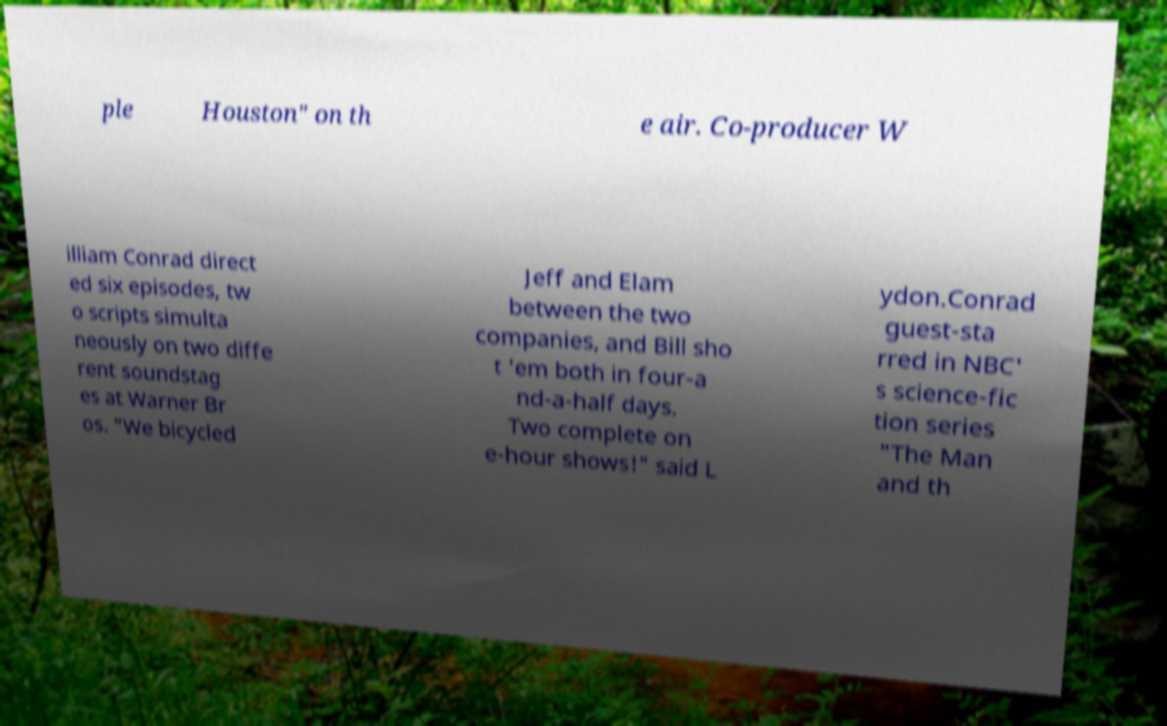Could you assist in decoding the text presented in this image and type it out clearly? ple Houston" on th e air. Co-producer W illiam Conrad direct ed six episodes, tw o scripts simulta neously on two diffe rent soundstag es at Warner Br os. "We bicycled Jeff and Elam between the two companies, and Bill sho t 'em both in four-a nd-a-half days. Two complete on e-hour shows!" said L ydon.Conrad guest-sta rred in NBC' s science-fic tion series "The Man and th 